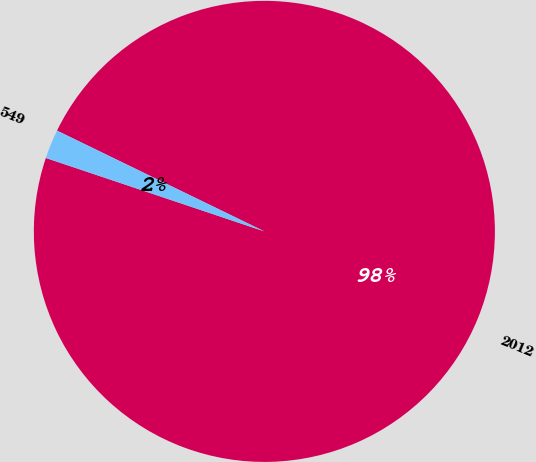<chart> <loc_0><loc_0><loc_500><loc_500><pie_chart><fcel>2012<fcel>549<nl><fcel>97.96%<fcel>2.04%<nl></chart> 